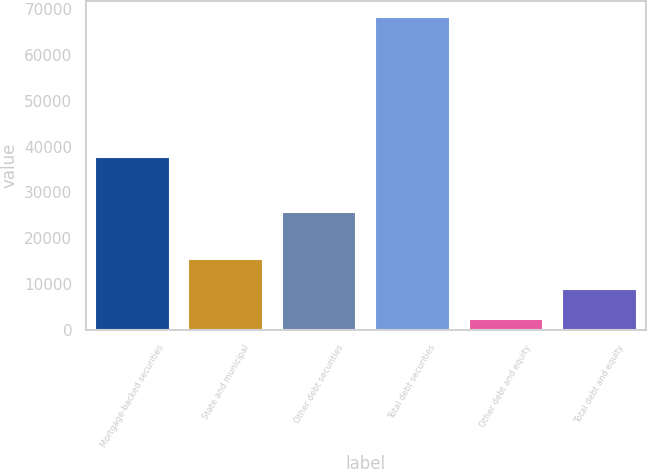<chart> <loc_0><loc_0><loc_500><loc_500><bar_chart><fcel>Mortgage-backed securities<fcel>State and municipal<fcel>Other debt securities<fcel>Total debt securities<fcel>Other debt and equity<fcel>Total debt and equity<nl><fcel>37719<fcel>15550.8<fcel>25665<fcel>68282<fcel>2368<fcel>8959.4<nl></chart> 